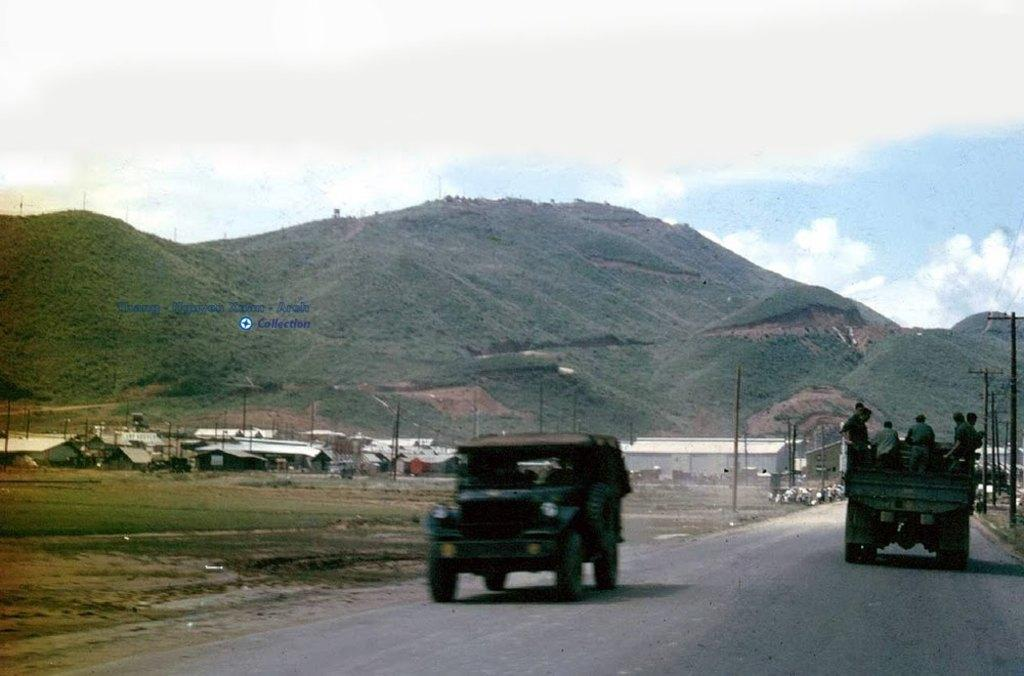What can be seen on the road in the image? There are vehicles on the road in the image. Can you identify any living beings in the image? Yes, there are people visible in the image. What type of vegetation is present in the image? There is grass in the image. What structures can be seen in the image? There are poles and sheds in the image. What natural feature is visible in the image? There is a mountain in the image. What is visible in the background of the image? The sky is visible in the background of the image, and there are clouds in the sky. Where is the airport located in the image? There is no airport present in the image. What type of picture is hanging on the wall in the image? There is no picture hanging on the wall in the image. What is the ball used for in the image? There is no ball present in the image. 